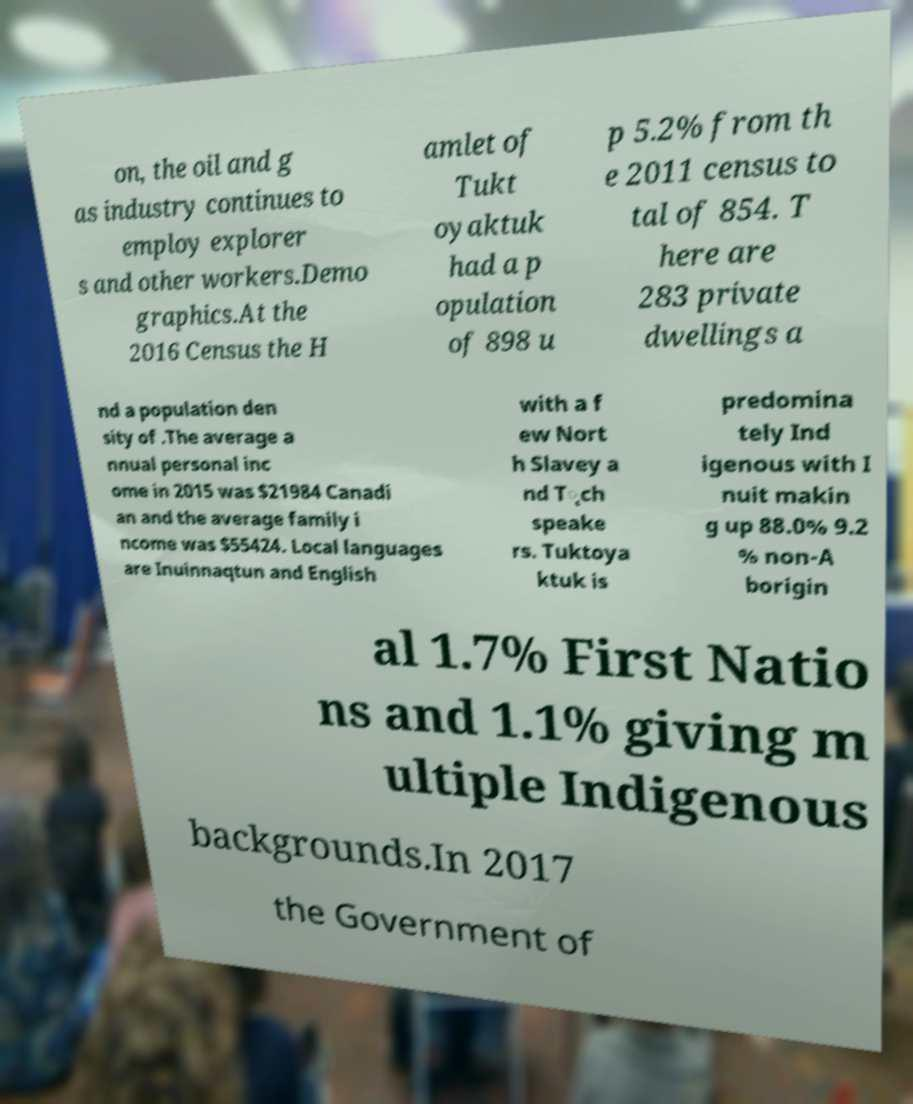Could you extract and type out the text from this image? on, the oil and g as industry continues to employ explorer s and other workers.Demo graphics.At the 2016 Census the H amlet of Tukt oyaktuk had a p opulation of 898 u p 5.2% from th e 2011 census to tal of 854. T here are 283 private dwellings a nd a population den sity of .The average a nnual personal inc ome in 2015 was $21984 Canadi an and the average family i ncome was $55424. Local languages are Inuinnaqtun and English with a f ew Nort h Slavey a nd T̨ch speake rs. Tuktoya ktuk is predomina tely Ind igenous with I nuit makin g up 88.0% 9.2 % non-A borigin al 1.7% First Natio ns and 1.1% giving m ultiple Indigenous backgrounds.In 2017 the Government of 